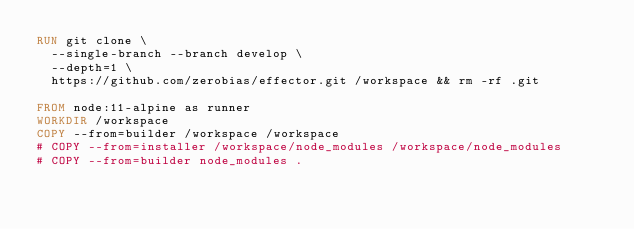<code> <loc_0><loc_0><loc_500><loc_500><_Dockerfile_>RUN git clone \
  --single-branch --branch develop \
  --depth=1 \
  https://github.com/zerobias/effector.git /workspace && rm -rf .git

FROM node:11-alpine as runner
WORKDIR /workspace
COPY --from=builder /workspace /workspace
# COPY --from=installer /workspace/node_modules /workspace/node_modules
# COPY --from=builder node_modules .</code> 